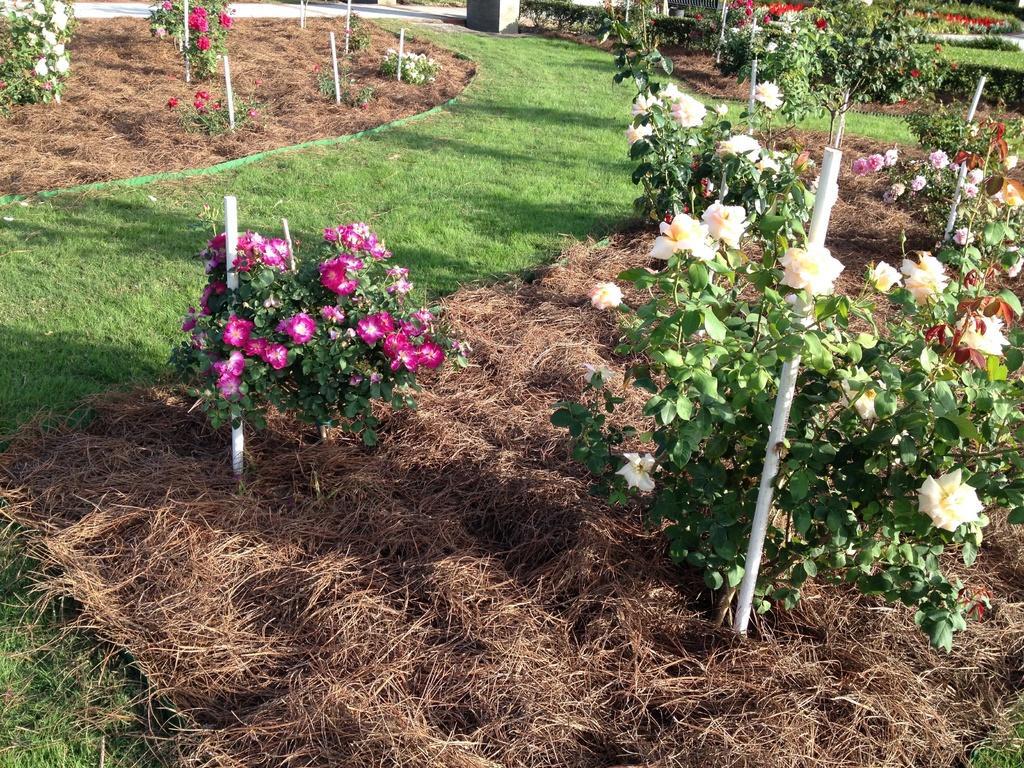In one or two sentences, can you explain what this image depicts? In this image there is a garden, in the garden there are some flower trees. 